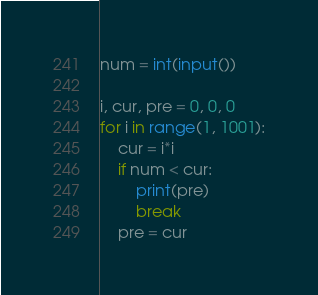<code> <loc_0><loc_0><loc_500><loc_500><_Python_>num = int(input())

i, cur, pre = 0, 0, 0
for i in range(1, 1001):
    cur = i*i
    if num < cur:
        print(pre)
        break
    pre = cur
</code> 